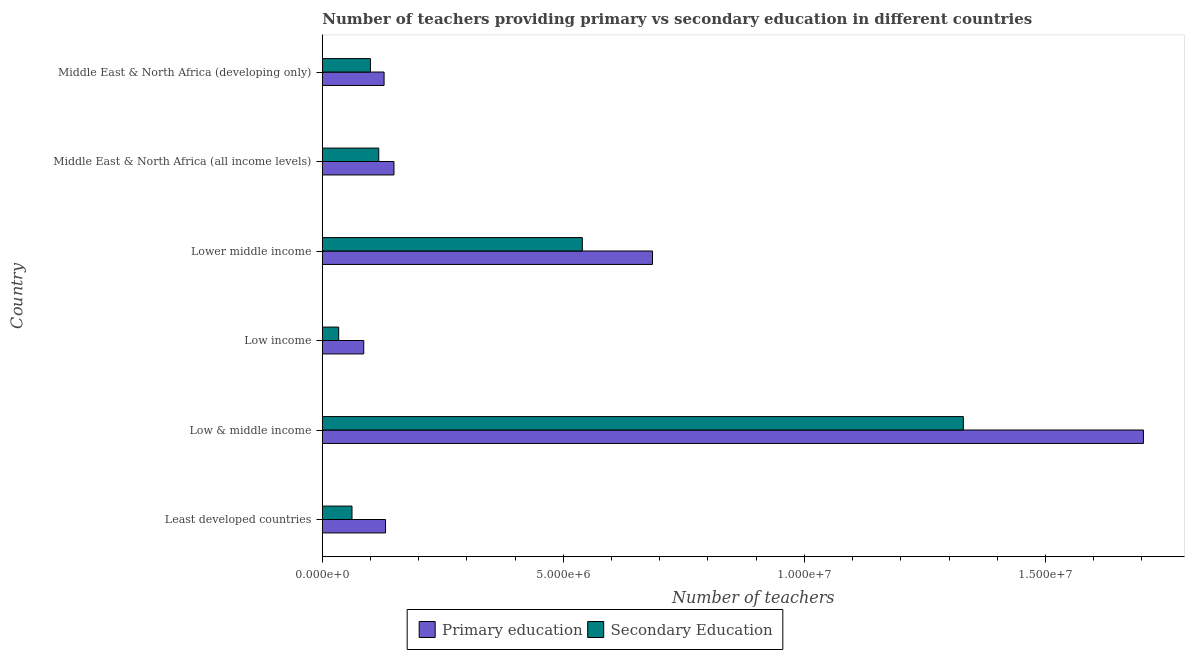How many bars are there on the 1st tick from the top?
Provide a short and direct response. 2. What is the label of the 1st group of bars from the top?
Provide a succinct answer. Middle East & North Africa (developing only). What is the number of secondary teachers in Low & middle income?
Offer a very short reply. 1.33e+07. Across all countries, what is the maximum number of secondary teachers?
Ensure brevity in your answer.  1.33e+07. Across all countries, what is the minimum number of secondary teachers?
Keep it short and to the point. 3.39e+05. In which country was the number of primary teachers minimum?
Your answer should be compact. Low income. What is the total number of secondary teachers in the graph?
Keep it short and to the point. 2.18e+07. What is the difference between the number of secondary teachers in Low & middle income and that in Low income?
Your answer should be compact. 1.30e+07. What is the difference between the number of secondary teachers in Low & middle income and the number of primary teachers in Middle East & North Africa (developing only)?
Provide a short and direct response. 1.20e+07. What is the average number of secondary teachers per country?
Provide a succinct answer. 3.64e+06. What is the difference between the number of secondary teachers and number of primary teachers in Middle East & North Africa (all income levels)?
Offer a terse response. -3.16e+05. In how many countries, is the number of secondary teachers greater than 16000000 ?
Keep it short and to the point. 0. What is the ratio of the number of secondary teachers in Low & middle income to that in Middle East & North Africa (all income levels)?
Your response must be concise. 11.36. What is the difference between the highest and the second highest number of primary teachers?
Your answer should be compact. 1.02e+07. What is the difference between the highest and the lowest number of secondary teachers?
Offer a terse response. 1.30e+07. In how many countries, is the number of secondary teachers greater than the average number of secondary teachers taken over all countries?
Make the answer very short. 2. What does the 1st bar from the top in Middle East & North Africa (all income levels) represents?
Give a very brief answer. Secondary Education. How many bars are there?
Offer a terse response. 12. What is the difference between two consecutive major ticks on the X-axis?
Keep it short and to the point. 5.00e+06. Does the graph contain any zero values?
Provide a succinct answer. No. How are the legend labels stacked?
Offer a very short reply. Horizontal. What is the title of the graph?
Provide a short and direct response. Number of teachers providing primary vs secondary education in different countries. Does "Female population" appear as one of the legend labels in the graph?
Make the answer very short. No. What is the label or title of the X-axis?
Offer a very short reply. Number of teachers. What is the label or title of the Y-axis?
Offer a very short reply. Country. What is the Number of teachers in Primary education in Least developed countries?
Make the answer very short. 1.31e+06. What is the Number of teachers in Secondary Education in Least developed countries?
Your answer should be very brief. 6.15e+05. What is the Number of teachers in Primary education in Low & middle income?
Make the answer very short. 1.70e+07. What is the Number of teachers in Secondary Education in Low & middle income?
Your answer should be very brief. 1.33e+07. What is the Number of teachers of Primary education in Low income?
Your answer should be very brief. 8.59e+05. What is the Number of teachers of Secondary Education in Low income?
Keep it short and to the point. 3.39e+05. What is the Number of teachers in Primary education in Lower middle income?
Your answer should be compact. 6.85e+06. What is the Number of teachers of Secondary Education in Lower middle income?
Ensure brevity in your answer.  5.39e+06. What is the Number of teachers in Primary education in Middle East & North Africa (all income levels)?
Keep it short and to the point. 1.49e+06. What is the Number of teachers in Secondary Education in Middle East & North Africa (all income levels)?
Offer a terse response. 1.17e+06. What is the Number of teachers in Primary education in Middle East & North Africa (developing only)?
Your answer should be compact. 1.28e+06. What is the Number of teachers of Secondary Education in Middle East & North Africa (developing only)?
Give a very brief answer. 9.98e+05. Across all countries, what is the maximum Number of teachers of Primary education?
Make the answer very short. 1.70e+07. Across all countries, what is the maximum Number of teachers in Secondary Education?
Give a very brief answer. 1.33e+07. Across all countries, what is the minimum Number of teachers of Primary education?
Offer a terse response. 8.59e+05. Across all countries, what is the minimum Number of teachers of Secondary Education?
Ensure brevity in your answer.  3.39e+05. What is the total Number of teachers in Primary education in the graph?
Keep it short and to the point. 2.88e+07. What is the total Number of teachers of Secondary Education in the graph?
Your response must be concise. 2.18e+07. What is the difference between the Number of teachers of Primary education in Least developed countries and that in Low & middle income?
Provide a succinct answer. -1.57e+07. What is the difference between the Number of teachers of Secondary Education in Least developed countries and that in Low & middle income?
Make the answer very short. -1.27e+07. What is the difference between the Number of teachers of Primary education in Least developed countries and that in Low income?
Keep it short and to the point. 4.52e+05. What is the difference between the Number of teachers in Secondary Education in Least developed countries and that in Low income?
Offer a very short reply. 2.76e+05. What is the difference between the Number of teachers in Primary education in Least developed countries and that in Lower middle income?
Offer a terse response. -5.54e+06. What is the difference between the Number of teachers in Secondary Education in Least developed countries and that in Lower middle income?
Provide a short and direct response. -4.78e+06. What is the difference between the Number of teachers in Primary education in Least developed countries and that in Middle East & North Africa (all income levels)?
Offer a very short reply. -1.75e+05. What is the difference between the Number of teachers in Secondary Education in Least developed countries and that in Middle East & North Africa (all income levels)?
Offer a terse response. -5.55e+05. What is the difference between the Number of teachers of Primary education in Least developed countries and that in Middle East & North Africa (developing only)?
Give a very brief answer. 3.02e+04. What is the difference between the Number of teachers in Secondary Education in Least developed countries and that in Middle East & North Africa (developing only)?
Your response must be concise. -3.82e+05. What is the difference between the Number of teachers in Primary education in Low & middle income and that in Low income?
Your answer should be very brief. 1.62e+07. What is the difference between the Number of teachers of Secondary Education in Low & middle income and that in Low income?
Your answer should be compact. 1.30e+07. What is the difference between the Number of teachers in Primary education in Low & middle income and that in Lower middle income?
Offer a very short reply. 1.02e+07. What is the difference between the Number of teachers in Secondary Education in Low & middle income and that in Lower middle income?
Your answer should be very brief. 7.90e+06. What is the difference between the Number of teachers of Primary education in Low & middle income and that in Middle East & North Africa (all income levels)?
Ensure brevity in your answer.  1.55e+07. What is the difference between the Number of teachers in Secondary Education in Low & middle income and that in Middle East & North Africa (all income levels)?
Your answer should be compact. 1.21e+07. What is the difference between the Number of teachers of Primary education in Low & middle income and that in Middle East & North Africa (developing only)?
Ensure brevity in your answer.  1.58e+07. What is the difference between the Number of teachers in Secondary Education in Low & middle income and that in Middle East & North Africa (developing only)?
Provide a succinct answer. 1.23e+07. What is the difference between the Number of teachers of Primary education in Low income and that in Lower middle income?
Ensure brevity in your answer.  -5.99e+06. What is the difference between the Number of teachers of Secondary Education in Low income and that in Lower middle income?
Your answer should be very brief. -5.05e+06. What is the difference between the Number of teachers in Primary education in Low income and that in Middle East & North Africa (all income levels)?
Your response must be concise. -6.27e+05. What is the difference between the Number of teachers in Secondary Education in Low income and that in Middle East & North Africa (all income levels)?
Provide a short and direct response. -8.31e+05. What is the difference between the Number of teachers of Primary education in Low income and that in Middle East & North Africa (developing only)?
Keep it short and to the point. -4.22e+05. What is the difference between the Number of teachers of Secondary Education in Low income and that in Middle East & North Africa (developing only)?
Provide a short and direct response. -6.58e+05. What is the difference between the Number of teachers in Primary education in Lower middle income and that in Middle East & North Africa (all income levels)?
Ensure brevity in your answer.  5.36e+06. What is the difference between the Number of teachers in Secondary Education in Lower middle income and that in Middle East & North Africa (all income levels)?
Give a very brief answer. 4.22e+06. What is the difference between the Number of teachers in Primary education in Lower middle income and that in Middle East & North Africa (developing only)?
Give a very brief answer. 5.57e+06. What is the difference between the Number of teachers of Secondary Education in Lower middle income and that in Middle East & North Africa (developing only)?
Your answer should be compact. 4.40e+06. What is the difference between the Number of teachers of Primary education in Middle East & North Africa (all income levels) and that in Middle East & North Africa (developing only)?
Your response must be concise. 2.06e+05. What is the difference between the Number of teachers in Secondary Education in Middle East & North Africa (all income levels) and that in Middle East & North Africa (developing only)?
Your answer should be compact. 1.73e+05. What is the difference between the Number of teachers of Primary education in Least developed countries and the Number of teachers of Secondary Education in Low & middle income?
Provide a short and direct response. -1.20e+07. What is the difference between the Number of teachers in Primary education in Least developed countries and the Number of teachers in Secondary Education in Low income?
Make the answer very short. 9.72e+05. What is the difference between the Number of teachers in Primary education in Least developed countries and the Number of teachers in Secondary Education in Lower middle income?
Provide a short and direct response. -4.08e+06. What is the difference between the Number of teachers of Primary education in Least developed countries and the Number of teachers of Secondary Education in Middle East & North Africa (all income levels)?
Keep it short and to the point. 1.40e+05. What is the difference between the Number of teachers of Primary education in Least developed countries and the Number of teachers of Secondary Education in Middle East & North Africa (developing only)?
Give a very brief answer. 3.13e+05. What is the difference between the Number of teachers in Primary education in Low & middle income and the Number of teachers in Secondary Education in Low income?
Make the answer very short. 1.67e+07. What is the difference between the Number of teachers of Primary education in Low & middle income and the Number of teachers of Secondary Education in Lower middle income?
Provide a short and direct response. 1.16e+07. What is the difference between the Number of teachers of Primary education in Low & middle income and the Number of teachers of Secondary Education in Middle East & North Africa (all income levels)?
Provide a succinct answer. 1.59e+07. What is the difference between the Number of teachers in Primary education in Low & middle income and the Number of teachers in Secondary Education in Middle East & North Africa (developing only)?
Provide a succinct answer. 1.60e+07. What is the difference between the Number of teachers of Primary education in Low income and the Number of teachers of Secondary Education in Lower middle income?
Your response must be concise. -4.53e+06. What is the difference between the Number of teachers of Primary education in Low income and the Number of teachers of Secondary Education in Middle East & North Africa (all income levels)?
Give a very brief answer. -3.11e+05. What is the difference between the Number of teachers of Primary education in Low income and the Number of teachers of Secondary Education in Middle East & North Africa (developing only)?
Offer a very short reply. -1.38e+05. What is the difference between the Number of teachers in Primary education in Lower middle income and the Number of teachers in Secondary Education in Middle East & North Africa (all income levels)?
Give a very brief answer. 5.68e+06. What is the difference between the Number of teachers of Primary education in Lower middle income and the Number of teachers of Secondary Education in Middle East & North Africa (developing only)?
Make the answer very short. 5.85e+06. What is the difference between the Number of teachers of Primary education in Middle East & North Africa (all income levels) and the Number of teachers of Secondary Education in Middle East & North Africa (developing only)?
Provide a short and direct response. 4.89e+05. What is the average Number of teachers in Primary education per country?
Make the answer very short. 4.80e+06. What is the average Number of teachers in Secondary Education per country?
Make the answer very short. 3.64e+06. What is the difference between the Number of teachers in Primary education and Number of teachers in Secondary Education in Least developed countries?
Provide a succinct answer. 6.96e+05. What is the difference between the Number of teachers in Primary education and Number of teachers in Secondary Education in Low & middle income?
Your answer should be compact. 3.74e+06. What is the difference between the Number of teachers in Primary education and Number of teachers in Secondary Education in Low income?
Offer a very short reply. 5.20e+05. What is the difference between the Number of teachers in Primary education and Number of teachers in Secondary Education in Lower middle income?
Provide a succinct answer. 1.46e+06. What is the difference between the Number of teachers of Primary education and Number of teachers of Secondary Education in Middle East & North Africa (all income levels)?
Your answer should be compact. 3.16e+05. What is the difference between the Number of teachers in Primary education and Number of teachers in Secondary Education in Middle East & North Africa (developing only)?
Provide a short and direct response. 2.83e+05. What is the ratio of the Number of teachers of Primary education in Least developed countries to that in Low & middle income?
Provide a succinct answer. 0.08. What is the ratio of the Number of teachers in Secondary Education in Least developed countries to that in Low & middle income?
Offer a very short reply. 0.05. What is the ratio of the Number of teachers of Primary education in Least developed countries to that in Low income?
Your answer should be compact. 1.53. What is the ratio of the Number of teachers of Secondary Education in Least developed countries to that in Low income?
Offer a terse response. 1.81. What is the ratio of the Number of teachers in Primary education in Least developed countries to that in Lower middle income?
Offer a very short reply. 0.19. What is the ratio of the Number of teachers in Secondary Education in Least developed countries to that in Lower middle income?
Provide a succinct answer. 0.11. What is the ratio of the Number of teachers of Primary education in Least developed countries to that in Middle East & North Africa (all income levels)?
Your response must be concise. 0.88. What is the ratio of the Number of teachers of Secondary Education in Least developed countries to that in Middle East & North Africa (all income levels)?
Provide a short and direct response. 0.53. What is the ratio of the Number of teachers of Primary education in Least developed countries to that in Middle East & North Africa (developing only)?
Offer a terse response. 1.02. What is the ratio of the Number of teachers of Secondary Education in Least developed countries to that in Middle East & North Africa (developing only)?
Keep it short and to the point. 0.62. What is the ratio of the Number of teachers of Primary education in Low & middle income to that in Low income?
Keep it short and to the point. 19.82. What is the ratio of the Number of teachers of Secondary Education in Low & middle income to that in Low income?
Your answer should be very brief. 39.19. What is the ratio of the Number of teachers in Primary education in Low & middle income to that in Lower middle income?
Offer a terse response. 2.49. What is the ratio of the Number of teachers in Secondary Education in Low & middle income to that in Lower middle income?
Your answer should be very brief. 2.47. What is the ratio of the Number of teachers in Primary education in Low & middle income to that in Middle East & North Africa (all income levels)?
Make the answer very short. 11.46. What is the ratio of the Number of teachers in Secondary Education in Low & middle income to that in Middle East & North Africa (all income levels)?
Offer a very short reply. 11.36. What is the ratio of the Number of teachers of Primary education in Low & middle income to that in Middle East & North Africa (developing only)?
Make the answer very short. 13.3. What is the ratio of the Number of teachers of Secondary Education in Low & middle income to that in Middle East & North Africa (developing only)?
Keep it short and to the point. 13.33. What is the ratio of the Number of teachers of Primary education in Low income to that in Lower middle income?
Offer a terse response. 0.13. What is the ratio of the Number of teachers of Secondary Education in Low income to that in Lower middle income?
Provide a succinct answer. 0.06. What is the ratio of the Number of teachers of Primary education in Low income to that in Middle East & North Africa (all income levels)?
Your response must be concise. 0.58. What is the ratio of the Number of teachers of Secondary Education in Low income to that in Middle East & North Africa (all income levels)?
Your answer should be very brief. 0.29. What is the ratio of the Number of teachers of Primary education in Low income to that in Middle East & North Africa (developing only)?
Your answer should be compact. 0.67. What is the ratio of the Number of teachers of Secondary Education in Low income to that in Middle East & North Africa (developing only)?
Ensure brevity in your answer.  0.34. What is the ratio of the Number of teachers of Primary education in Lower middle income to that in Middle East & North Africa (all income levels)?
Give a very brief answer. 4.61. What is the ratio of the Number of teachers of Secondary Education in Lower middle income to that in Middle East & North Africa (all income levels)?
Offer a terse response. 4.61. What is the ratio of the Number of teachers of Primary education in Lower middle income to that in Middle East & North Africa (developing only)?
Provide a short and direct response. 5.35. What is the ratio of the Number of teachers of Secondary Education in Lower middle income to that in Middle East & North Africa (developing only)?
Your answer should be compact. 5.41. What is the ratio of the Number of teachers of Primary education in Middle East & North Africa (all income levels) to that in Middle East & North Africa (developing only)?
Your answer should be very brief. 1.16. What is the ratio of the Number of teachers of Secondary Education in Middle East & North Africa (all income levels) to that in Middle East & North Africa (developing only)?
Your answer should be very brief. 1.17. What is the difference between the highest and the second highest Number of teachers of Primary education?
Make the answer very short. 1.02e+07. What is the difference between the highest and the second highest Number of teachers in Secondary Education?
Your answer should be compact. 7.90e+06. What is the difference between the highest and the lowest Number of teachers of Primary education?
Provide a short and direct response. 1.62e+07. What is the difference between the highest and the lowest Number of teachers in Secondary Education?
Provide a short and direct response. 1.30e+07. 